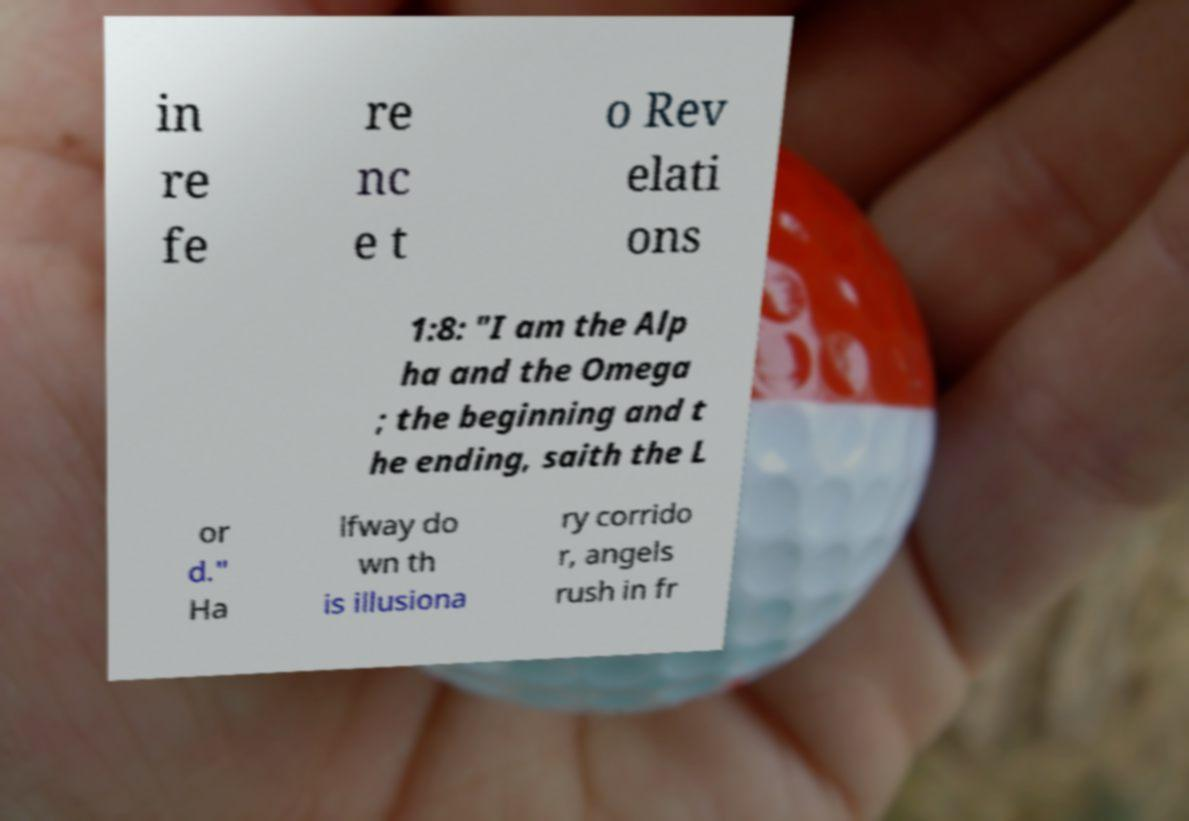Can you accurately transcribe the text from the provided image for me? in re fe re nc e t o Rev elati ons 1:8: "I am the Alp ha and the Omega ; the beginning and t he ending, saith the L or d." Ha lfway do wn th is illusiona ry corrido r, angels rush in fr 